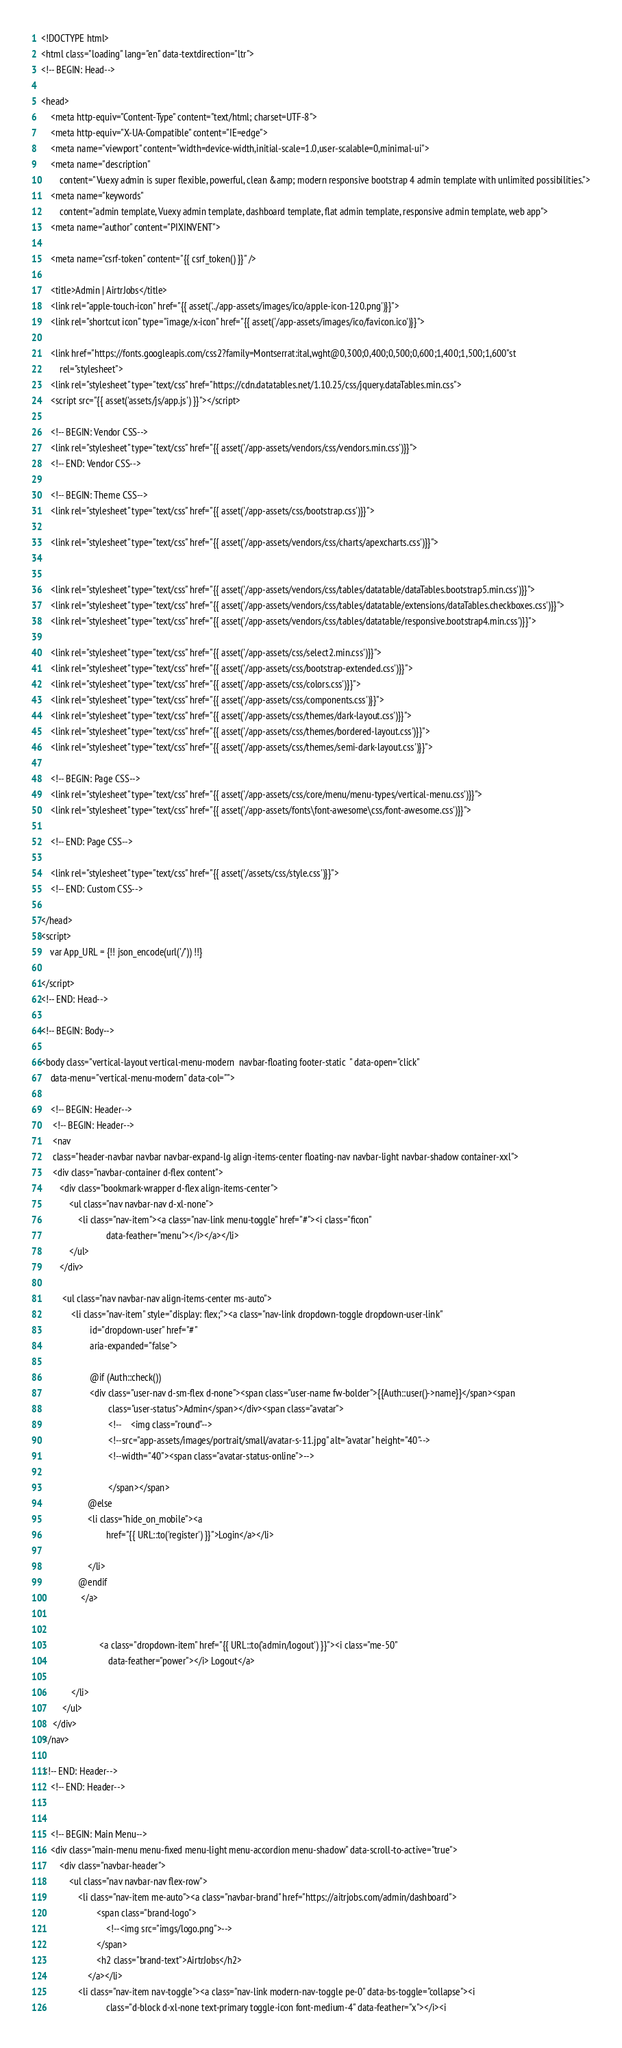<code> <loc_0><loc_0><loc_500><loc_500><_PHP_><!DOCTYPE html>
<html class="loading" lang="en" data-textdirection="ltr">
<!-- BEGIN: Head-->

<head>
    <meta http-equiv="Content-Type" content="text/html; charset=UTF-8">
    <meta http-equiv="X-UA-Compatible" content="IE=edge">
    <meta name="viewport" content="width=device-width,initial-scale=1.0,user-scalable=0,minimal-ui">
    <meta name="description"
        content="Vuexy admin is super flexible, powerful, clean &amp; modern responsive bootstrap 4 admin template with unlimited possibilities.">
    <meta name="keywords"
        content="admin template, Vuexy admin template, dashboard template, flat admin template, responsive admin template, web app">
    <meta name="author" content="PIXINVENT">

    <meta name="csrf-token" content="{{ csrf_token() }}" /> 

    <title>Admin | AirtrJobs</title>
    <link rel="apple-touch-icon" href="{{ asset('../app-assets/images/ico/apple-icon-120.png')}}">
    <link rel="shortcut icon" type="image/x-icon" href="{{ asset('/app-assets/images/ico/favicon.ico')}}">

    <link href="https://fonts.googleapis.com/css2?family=Montserrat:ital,wght@0,300;0,400;0,500;0,600;1,400;1,500;1,600"st
        rel="stylesheet">
    <link rel="stylesheet" type="text/css" href="https://cdn.datatables.net/1.10.25/css/jquery.dataTables.min.css">
    <script src="{{ asset('assets/js/app.js') }}"></script>

    <!-- BEGIN: Vendor CSS-->
    <link rel="stylesheet" type="text/css" href="{{ asset('/app-assets/vendors/css/vendors.min.css')}}">
    <!-- END: Vendor CSS-->

    <!-- BEGIN: Theme CSS-->
    <link rel="stylesheet" type="text/css" href="{{ asset('/app-assets/css/bootstrap.css')}}">

    <link rel="stylesheet" type="text/css" href="{{ asset('/app-assets/vendors/css/charts/apexcharts.css')}}">
      
    
    <link rel="stylesheet" type="text/css" href="{{ asset('/app-assets/vendors/css/tables/datatable/dataTables.bootstrap5.min.css')}}">
    <link rel="stylesheet" type="text/css" href="{{ asset('/app-assets/vendors/css/tables/datatable/extensions/dataTables.checkboxes.css')}}">
    <link rel="stylesheet" type="text/css" href="{{ asset('/app-assets/vendors/css/tables/datatable/responsive.bootstrap4.min.css')}}">

    <link rel="stylesheet" type="text/css" href="{{ asset('/app-assets/css/select2.min.css')}}">
    <link rel="stylesheet" type="text/css" href="{{ asset('/app-assets/css/bootstrap-extended.css')}}">
    <link rel="stylesheet" type="text/css" href="{{ asset('/app-assets/css/colors.css')}}">
    <link rel="stylesheet" type="text/css" href="{{ asset('/app-assets/css/components.css')}}">
    <link rel="stylesheet" type="text/css" href="{{ asset('/app-assets/css/themes/dark-layout.css')}}">
    <link rel="stylesheet" type="text/css" href="{{ asset('/app-assets/css/themes/bordered-layout.css')}}">
    <link rel="stylesheet" type="text/css" href="{{ asset('/app-assets/css/themes/semi-dark-layout.css')}}">

    <!-- BEGIN: Page CSS-->
    <link rel="stylesheet" type="text/css" href="{{ asset('/app-assets/css/core/menu/menu-types/vertical-menu.css')}}">
    <link rel="stylesheet" type="text/css" href="{{ asset('/app-assets/fonts\font-awesome\css/font-awesome.css')}}">

    <!-- END: Page CSS-->

    <link rel="stylesheet" type="text/css" href="{{ asset('/assets/css/style.css')}}">
    <!-- END: Custom CSS-->

</head>
<script>
    var App_URL = {!! json_encode(url('/')) !!}
    
</script>
<!-- END: Head-->

<!-- BEGIN: Body-->

<body class="vertical-layout vertical-menu-modern  navbar-floating footer-static  " data-open="click"
    data-menu="vertical-menu-modern" data-col="">

    <!-- BEGIN: Header-->
     <!-- BEGIN: Header-->
     <nav
     class="header-navbar navbar navbar-expand-lg align-items-center floating-nav navbar-light navbar-shadow container-xxl">
     <div class="navbar-container d-flex content">
        <div class="bookmark-wrapper d-flex align-items-center">
            <ul class="nav navbar-nav d-xl-none">
                <li class="nav-item"><a class="nav-link menu-toggle" href="#"><i class="ficon"
                            data-feather="menu"></i></a></li>
            </ul>
        </div>
     
         <ul class="nav navbar-nav align-items-center ms-auto">
             <li class="nav-item" style="display: flex;"><a class="nav-link dropdown-toggle dropdown-user-link"
                     id="dropdown-user" href="#" 
                     aria-expanded="false">
                 
                     @if (Auth::check())
                     <div class="user-nav d-sm-flex d-none"><span class="user-name fw-bolder">{{Auth::user()->name}}</span><span
                             class="user-status">Admin</span></div><span class="avatar">
                             <!--    <img class="round"-->
                             <!--src="app-assets/images/portrait/small/avatar-s-11.jpg" alt="avatar" height="40"-->
                             <!--width="40"><span class="avatar-status-online">-->
                                 
                             </span></span>
                    @else
                    <li class="hide_on_mobile"><a
                            href="{{ URL::to('register') }}">Login</a></li>
                    
                    </li>
                @endif
                 </a>
                 
                     
                         <a class="dropdown-item" href="{{ URL::to('admin/logout') }}"><i class="me-50"
                             data-feather="power"></i> Logout</a>
                 
             </li>
         </ul>
     </div>
 </nav>

 <!-- END: Header-->
    <!-- END: Header-->


    <!-- BEGIN: Main Menu-->
    <div class="main-menu menu-fixed menu-light menu-accordion menu-shadow" data-scroll-to-active="true">
        <div class="navbar-header">
            <ul class="nav navbar-nav flex-row">
                <li class="nav-item me-auto"><a class="navbar-brand" href="https://aitrjobs.com/admin/dashboard">
                        <span class="brand-logo">
                            <!--<img src="imgs/logo.png">-->
                        </span>
                        <h2 class="brand-text">AirtrJobs</h2>
                    </a></li>
                <li class="nav-item nav-toggle"><a class="nav-link modern-nav-toggle pe-0" data-bs-toggle="collapse"><i
                            class="d-block d-xl-none text-primary toggle-icon font-medium-4" data-feather="x"></i><i</code> 